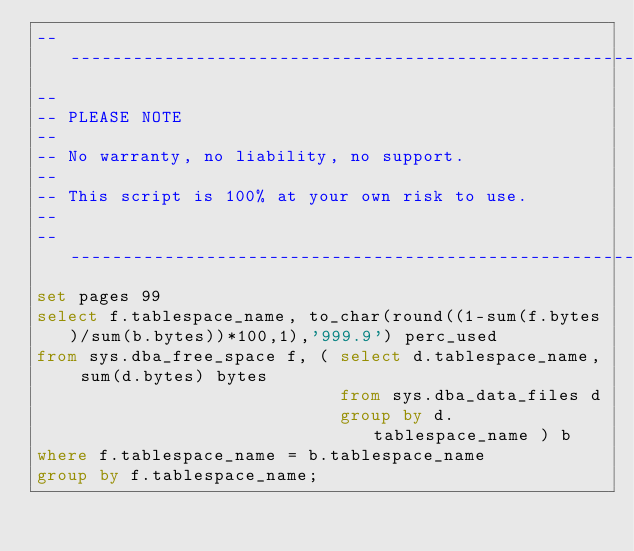<code> <loc_0><loc_0><loc_500><loc_500><_SQL_>-------------------------------------------------------------------------------
--
-- PLEASE NOTE
-- 
-- No warranty, no liability, no support.
--
-- This script is 100% at your own risk to use.
--
-------------------------------------------------------------------------------
set pages 99
select f.tablespace_name, to_char(round((1-sum(f.bytes)/sum(b.bytes))*100,1),'999.9') perc_used
from sys.dba_free_space f, ( select d.tablespace_name, sum(d.bytes) bytes 
                             from sys.dba_data_files d
                             group by d.tablespace_name ) b
where f.tablespace_name = b.tablespace_name
group by f.tablespace_name;
</code> 